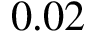<formula> <loc_0><loc_0><loc_500><loc_500>0 . 0 2</formula> 